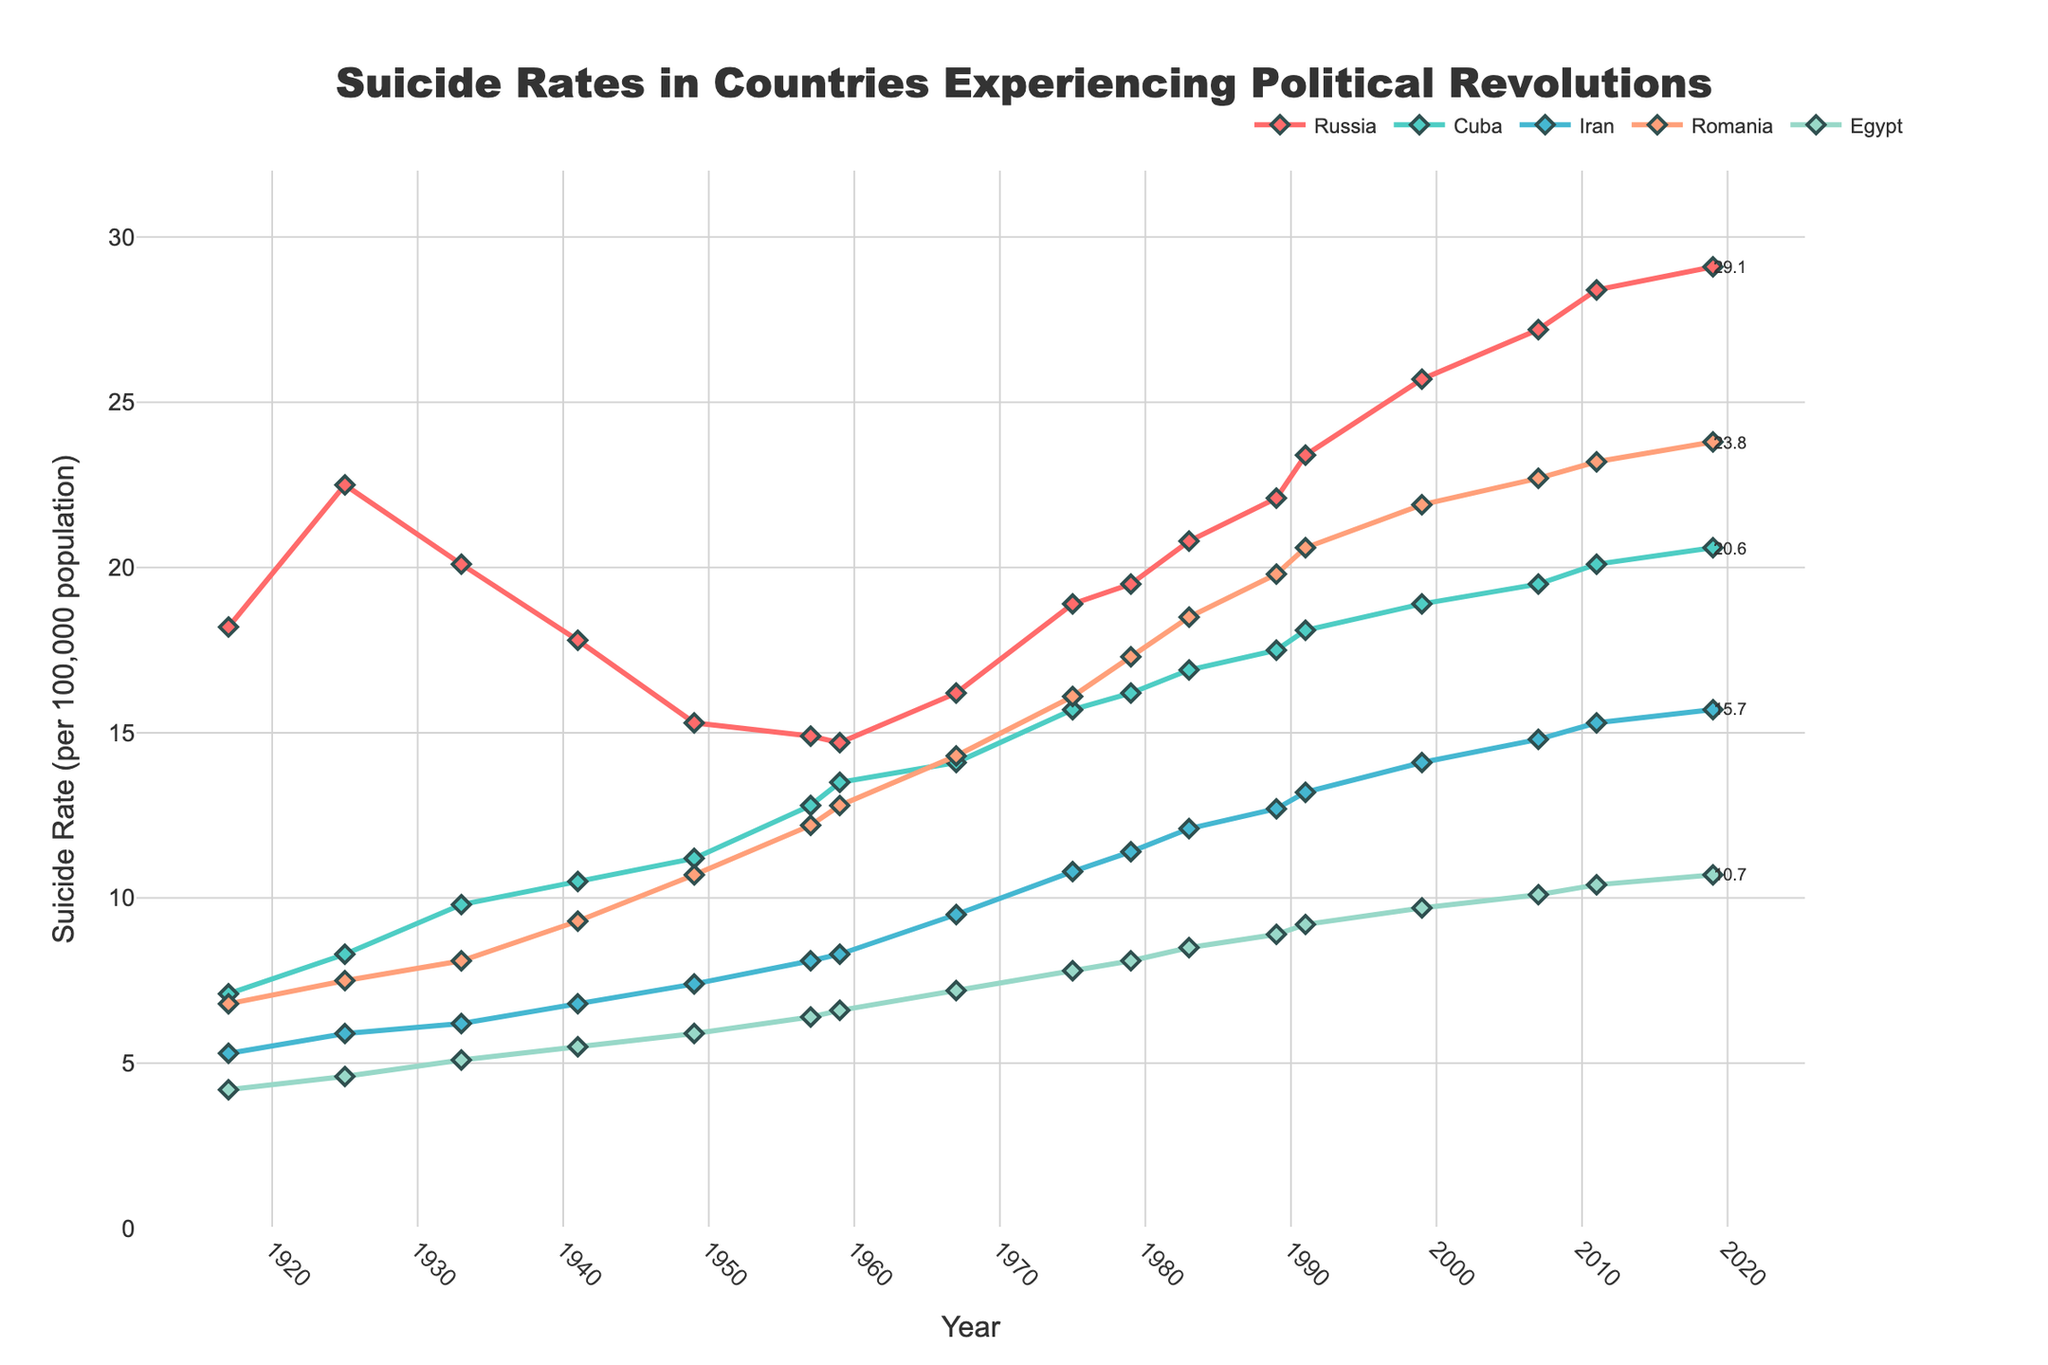Which country had the highest suicide rate in 2019? Looking at the end points of the lines for 2019, Russia had the highest suicide rate, indicated by the highest point on the figure.
Answer: Russia What is the difference in suicide rates between Egypt and Iran in 2011? Locate the suicide rates of Egypt and Iran in 2011, then subtract Egypt's rate (10.4) from Iran's rate (15.3). So, 15.3 - 10.4 = 4.9.
Answer: 4.9 Which country experienced the highest increase in suicide rates from 1917 to 2019? By comparing the initial and final values for each country, Russia's increase from 18.2 in 1917 to 29.1 in 2019 is the highest.
Answer: Russia What was the average suicide rate of Romania from 1957 to 1967? Locate suicide rates for Romania in 1957 (12.2) and 1967 (14.3), then calculate the average: (12.2 + 14.3) / 2 = 13.25.
Answer: 13.25 How many countries had a suicide rate over 20 in 1991? Identify the countries with suicide rates above 20 by observing the 1991 data points: Russia, Cuba, Romania. Three countries exceed 20 in 1991.
Answer: 3 Among the countries listed, which had the most consistent increase in suicide rates over the century? Identify a country where the line plot shows a steady increase; Cuba shows a consistent upward trend without any decrease.
Answer: Cuba In which year did Romania's suicide rate first exceed 20? Locate the point where Romania's line crosses the 20 mark; it first occurs in 1989.
Answer: 1989 What is the average suicide rate in 1979 across all countries? Find the suicide rates for all countries in 1979 (Russia: 19.5, Cuba: 16.2, Iran: 11.4, Romania: 17.3, Egypt: 8.1) and calculate the average: (19.5 + 16.2 + 11.4 + 17.3 + 8.1) / 5 = 14.5.
Answer: 14.5 Which country had the sharpest decline in suicide rates between two consecutive data points, and what was the difference? Romania's decline from 10.7 in 1949 to 8.1 in 1933 is the sharpest. Calculate the difference: 10.7 - 8.1 = 2.6.
Answer: Romania, 2.6 By how much did the suicide rate in Russia change from 1989 to 1999? Find Russia's suicide rates in 1989 (22.1) and 1999 (25.7), and then calculate the difference: 25.7 - 22.1 = 3.6.
Answer: 3.6 